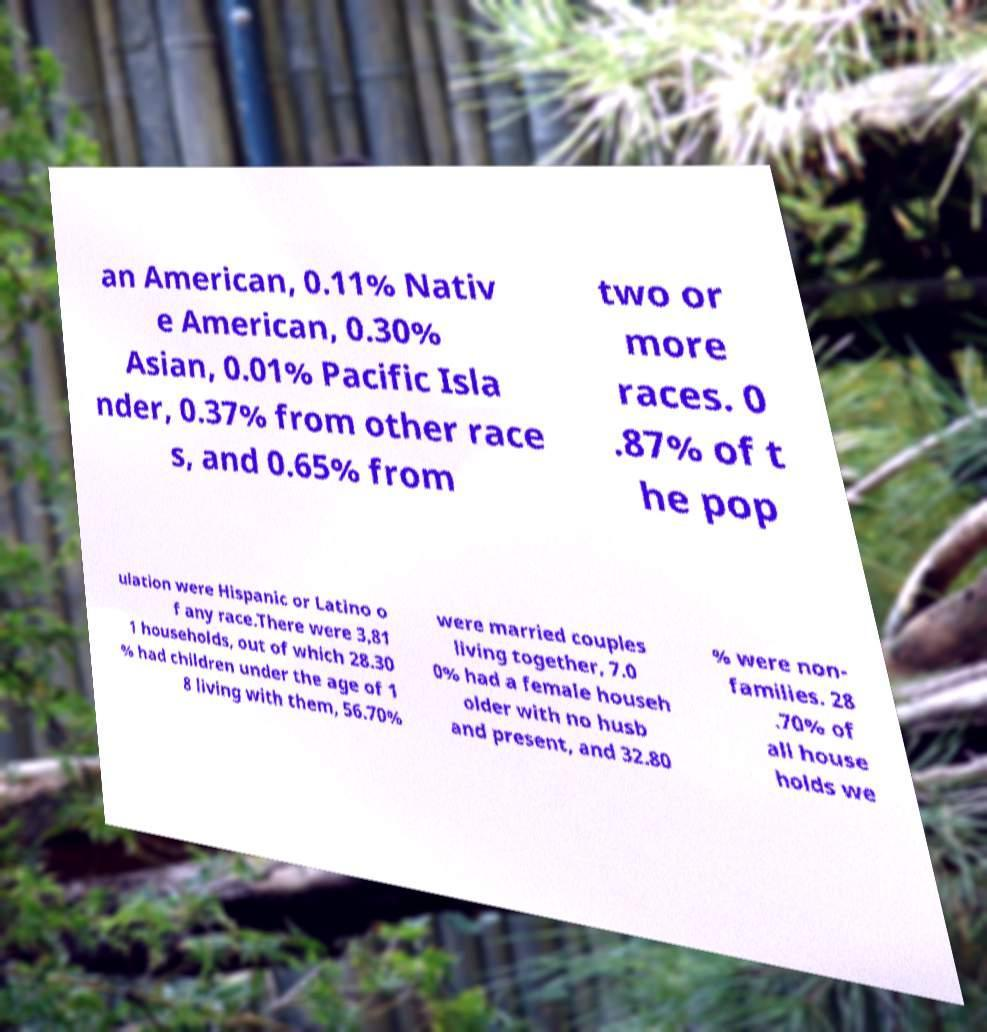What messages or text are displayed in this image? I need them in a readable, typed format. an American, 0.11% Nativ e American, 0.30% Asian, 0.01% Pacific Isla nder, 0.37% from other race s, and 0.65% from two or more races. 0 .87% of t he pop ulation were Hispanic or Latino o f any race.There were 3,81 1 households, out of which 28.30 % had children under the age of 1 8 living with them, 56.70% were married couples living together, 7.0 0% had a female househ older with no husb and present, and 32.80 % were non- families. 28 .70% of all house holds we 